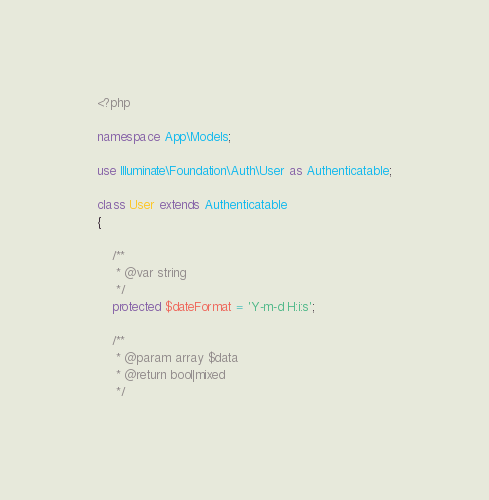<code> <loc_0><loc_0><loc_500><loc_500><_PHP_><?php

namespace App\Models;

use Illuminate\Foundation\Auth\User as Authenticatable;

class User extends Authenticatable
{

    /**
     * @var string
     */
    protected $dateFormat = 'Y-m-d H:i:s';

    /**
     * @param array $data
     * @return bool|mixed
     */</code> 